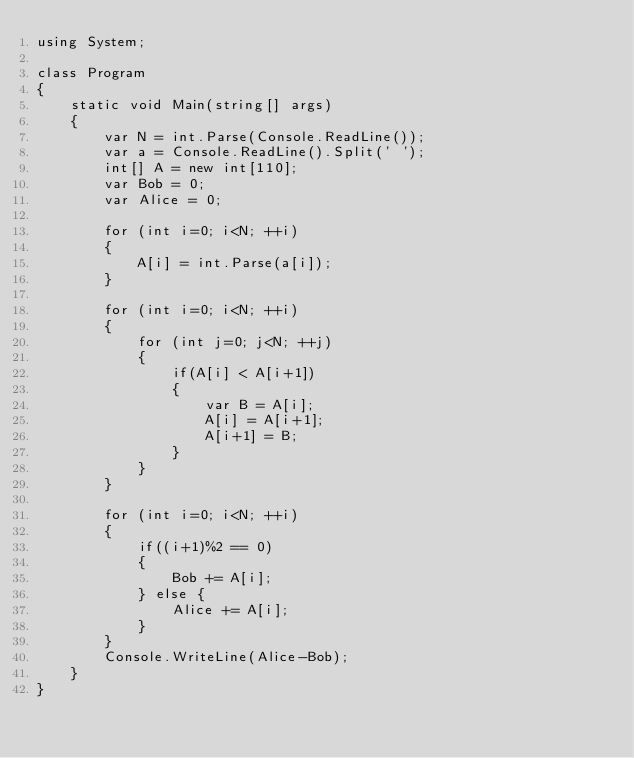Convert code to text. <code><loc_0><loc_0><loc_500><loc_500><_C#_>using System;

class Program
{
    static void Main(string[] args)
    {
        var N = int.Parse(Console.ReadLine());
        var a = Console.ReadLine().Split(' ');
        int[] A = new int[110];
        var Bob = 0;
        var Alice = 0;
        
        for (int i=0; i<N; ++i)
        {
            A[i] = int.Parse(a[i]);
        }

        for (int i=0; i<N; ++i)
        {
            for (int j=0; j<N; ++j)
            {
                if(A[i] < A[i+1])
                {
                    var B = A[i];
                    A[i] = A[i+1];
                    A[i+1] = B;
                }
            }
        }

        for (int i=0; i<N; ++i)
        {
            if((i+1)%2 == 0)
            {
                Bob += A[i];
            } else {
                Alice += A[i];
            }
        }
        Console.WriteLine(Alice-Bob);
    }
}</code> 